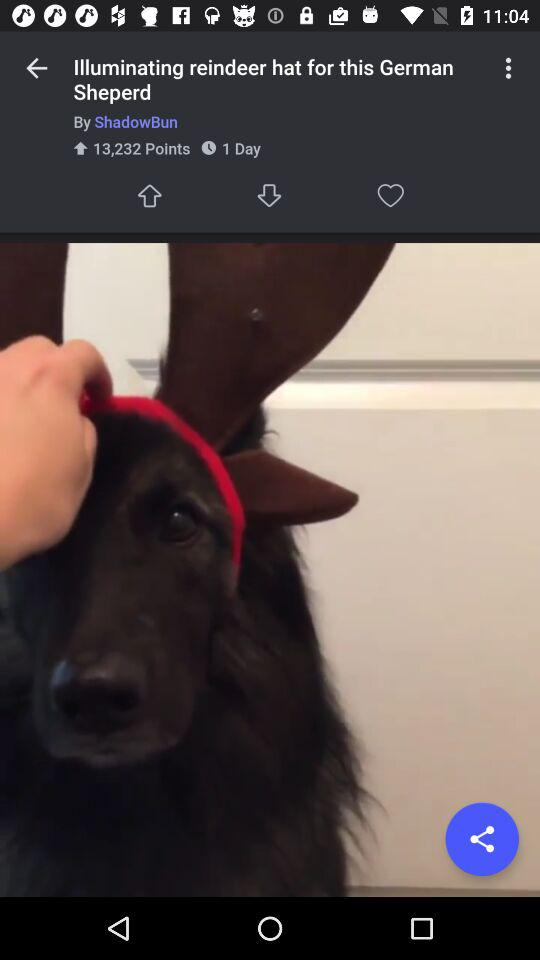How many points are there? There are 13,232 points. 